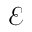<formula> <loc_0><loc_0><loc_500><loc_500>\mathcal { E }</formula> 